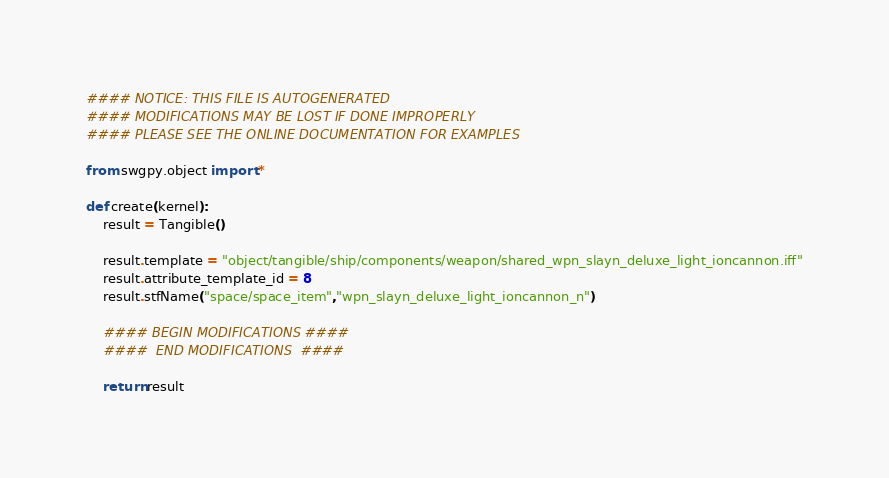Convert code to text. <code><loc_0><loc_0><loc_500><loc_500><_Python_>#### NOTICE: THIS FILE IS AUTOGENERATED
#### MODIFICATIONS MAY BE LOST IF DONE IMPROPERLY
#### PLEASE SEE THE ONLINE DOCUMENTATION FOR EXAMPLES

from swgpy.object import *	

def create(kernel):
	result = Tangible()

	result.template = "object/tangible/ship/components/weapon/shared_wpn_slayn_deluxe_light_ioncannon.iff"
	result.attribute_template_id = 8
	result.stfName("space/space_item","wpn_slayn_deluxe_light_ioncannon_n")		
	
	#### BEGIN MODIFICATIONS ####
	####  END MODIFICATIONS  ####
	
	return result</code> 